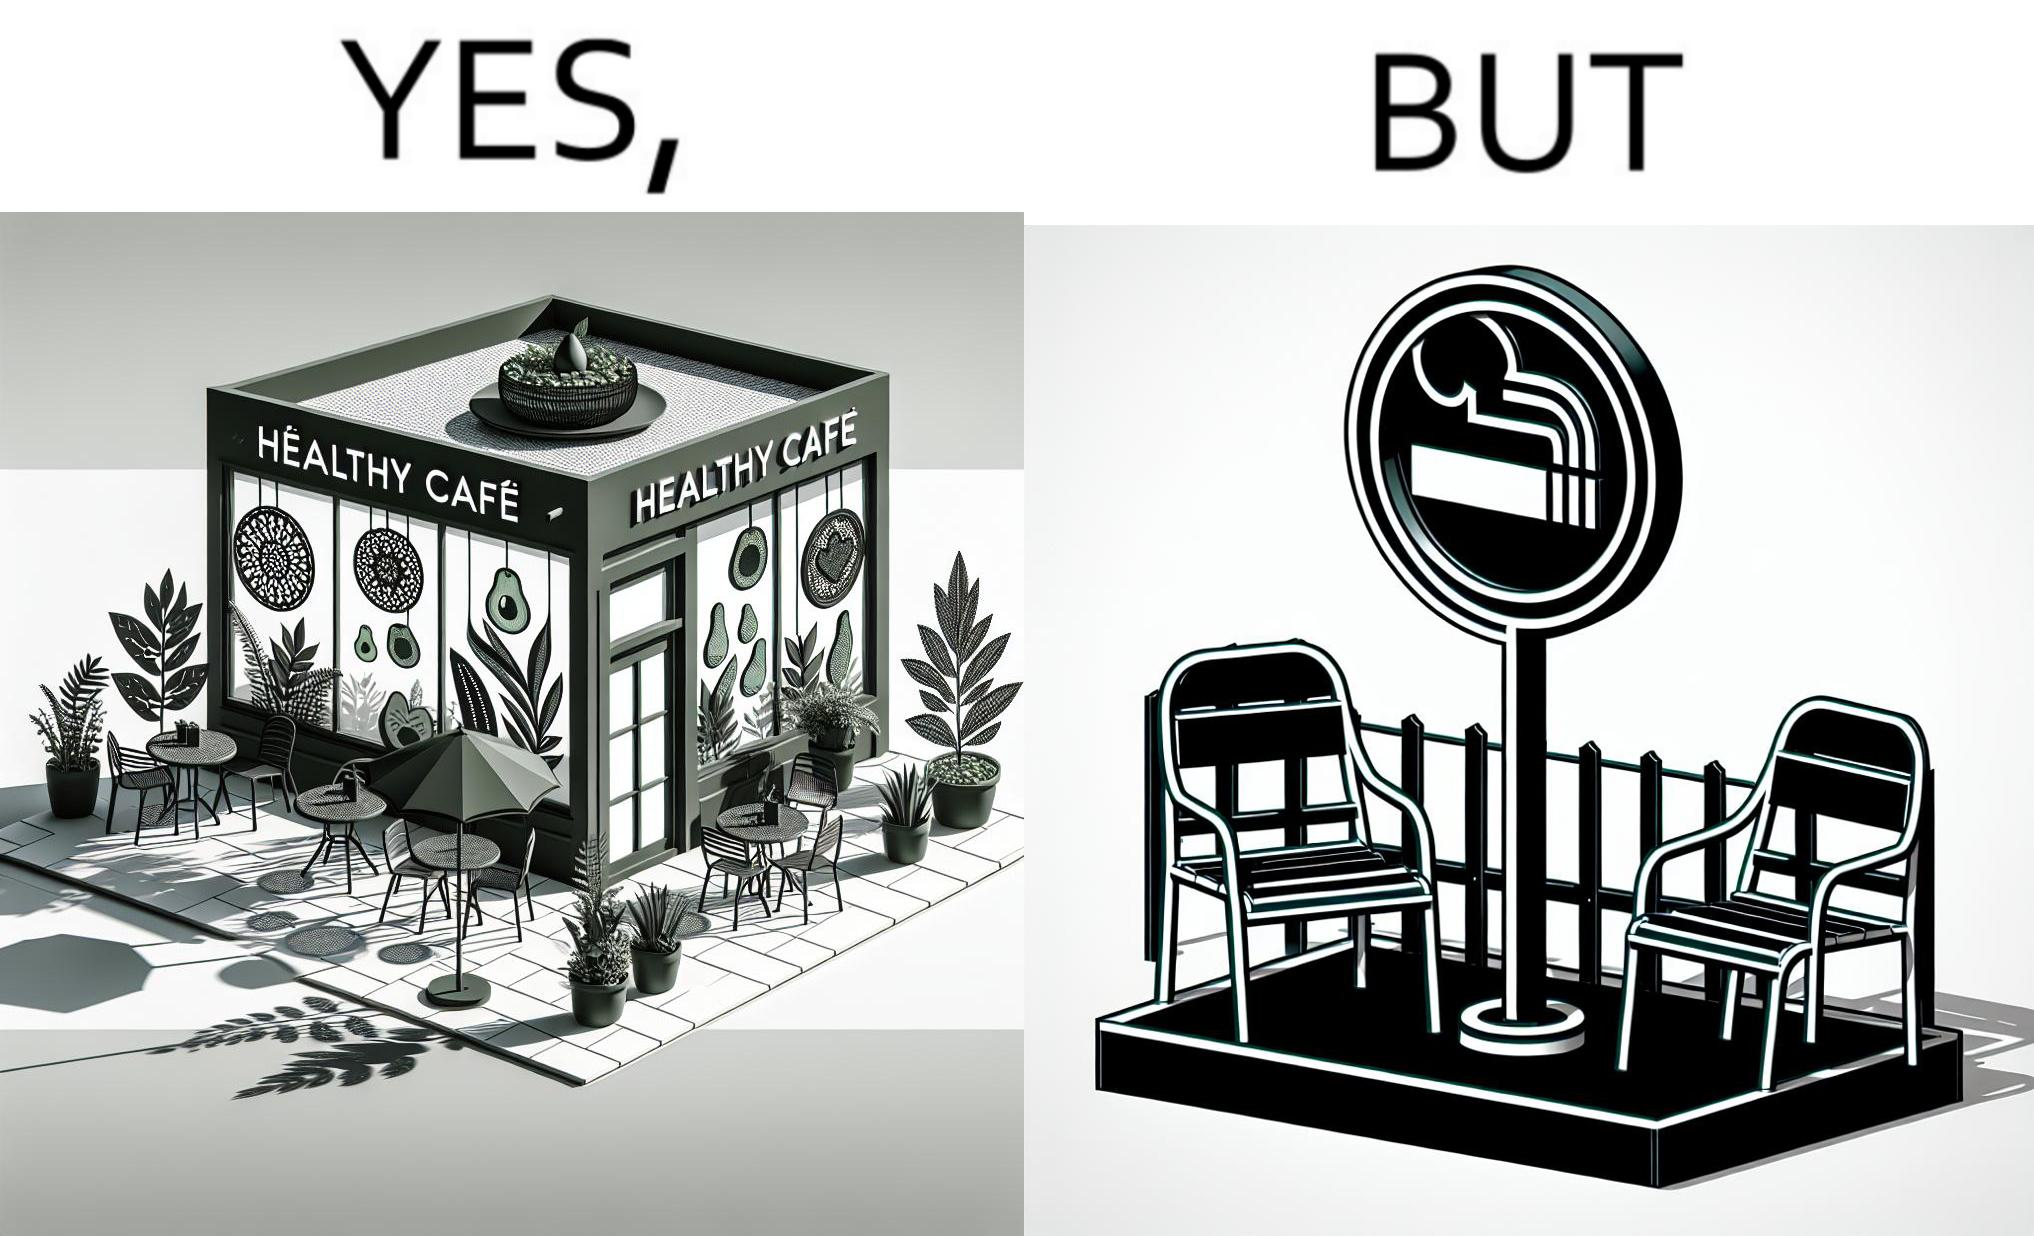Is this a satirical image? Yes, this image is satirical. 